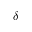Convert formula to latex. <formula><loc_0><loc_0><loc_500><loc_500>\delta</formula> 